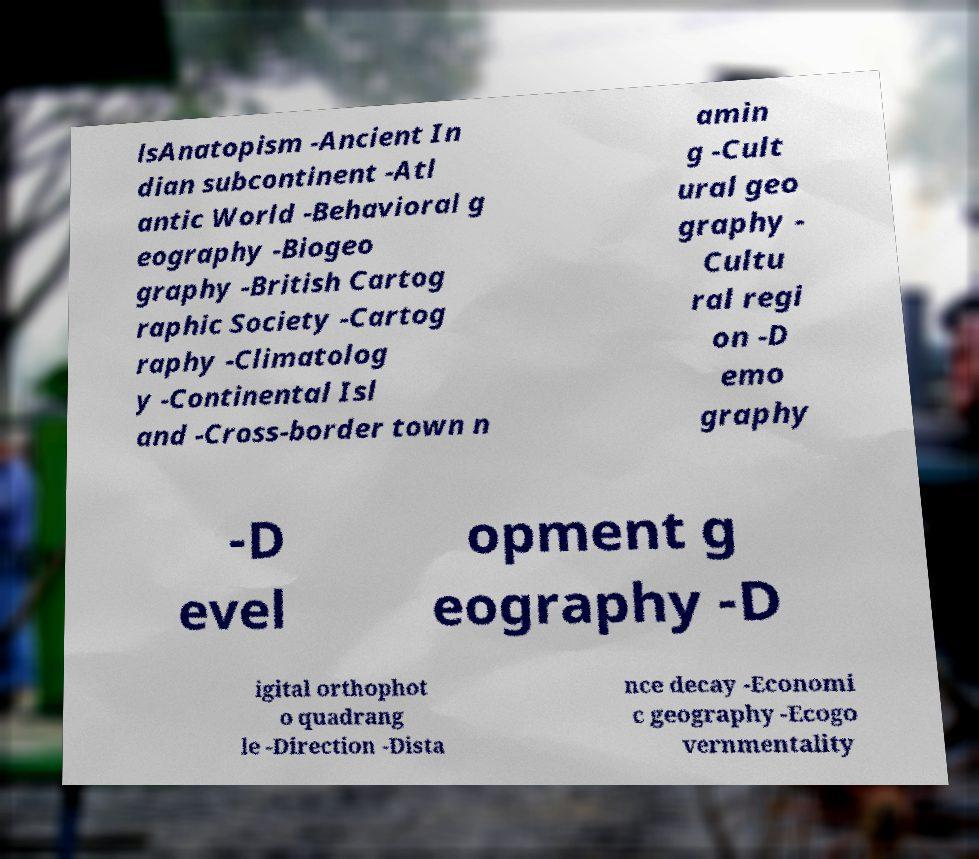Can you accurately transcribe the text from the provided image for me? lsAnatopism -Ancient In dian subcontinent -Atl antic World -Behavioral g eography -Biogeo graphy -British Cartog raphic Society -Cartog raphy -Climatolog y -Continental Isl and -Cross-border town n amin g -Cult ural geo graphy - Cultu ral regi on -D emo graphy -D evel opment g eography -D igital orthophot o quadrang le -Direction -Dista nce decay -Economi c geography -Ecogo vernmentality 